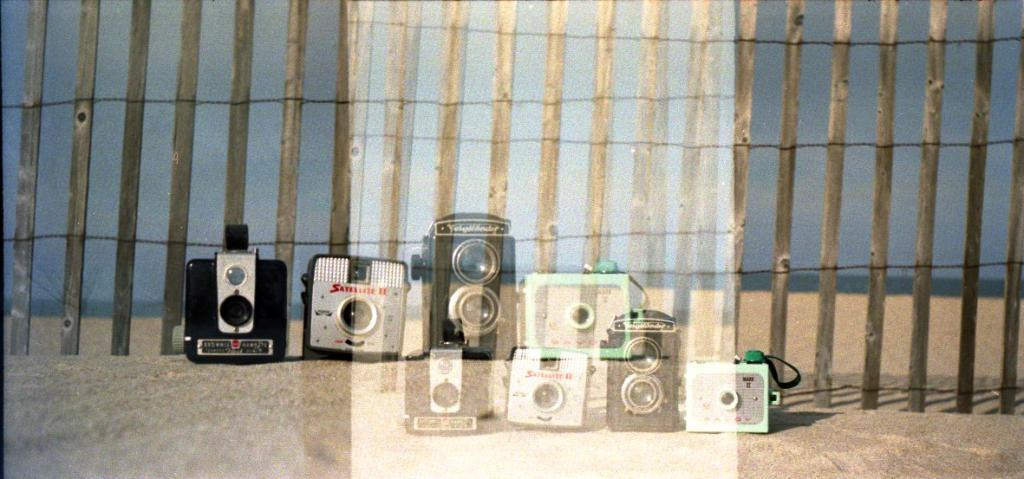What objects are present on the road in the image? There are cameras on the road in the image. What can be seen in the background of the image? There are sticks visible in the background of the image. What type of mass is being transported on the road in the image? There is no mass being transported on the road in the image; the main subject is the cameras. Can you see an apple in the image? There is no apple present in the image. 